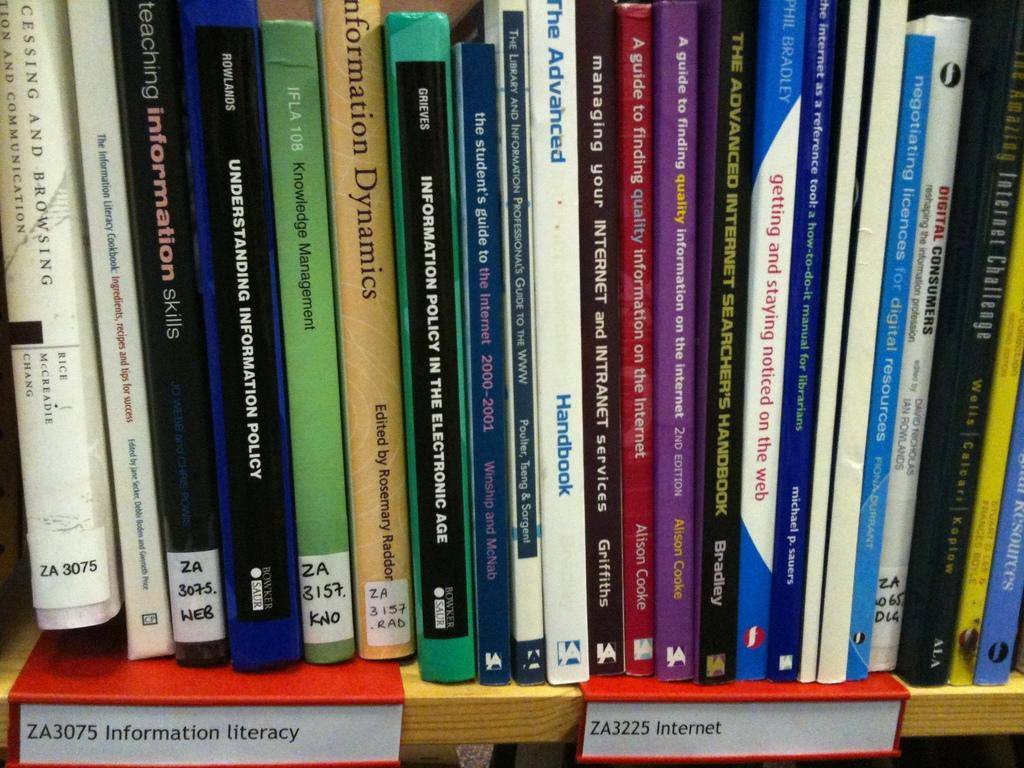<image>
Relay a brief, clear account of the picture shown. Library books lined up on a shelf with labels stating "Information literacy" and "Internet". 